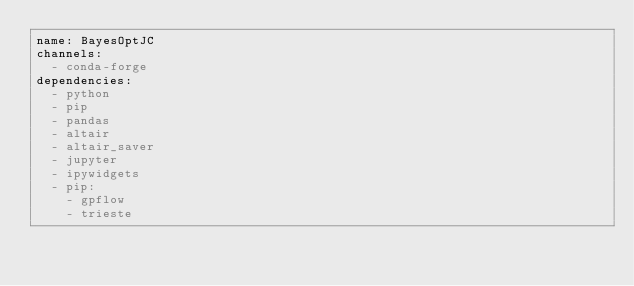Convert code to text. <code><loc_0><loc_0><loc_500><loc_500><_YAML_>name: BayesOptJC
channels:
  - conda-forge
dependencies:
  - python
  - pip
  - pandas
  - altair
  - altair_saver
  - jupyter
  - ipywidgets
  - pip:
    - gpflow
    - trieste
</code> 